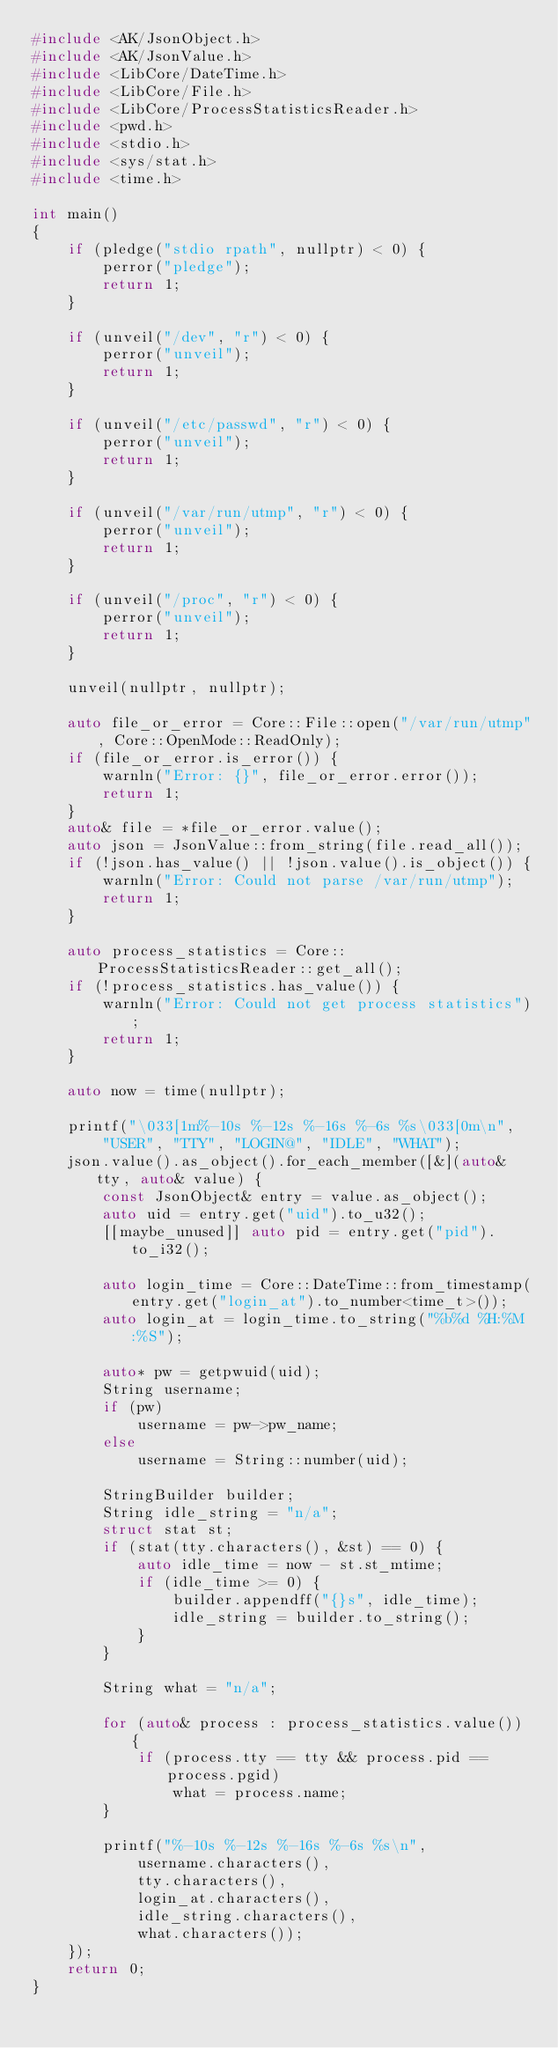Convert code to text. <code><loc_0><loc_0><loc_500><loc_500><_C++_>#include <AK/JsonObject.h>
#include <AK/JsonValue.h>
#include <LibCore/DateTime.h>
#include <LibCore/File.h>
#include <LibCore/ProcessStatisticsReader.h>
#include <pwd.h>
#include <stdio.h>
#include <sys/stat.h>
#include <time.h>

int main()
{
    if (pledge("stdio rpath", nullptr) < 0) {
        perror("pledge");
        return 1;
    }

    if (unveil("/dev", "r") < 0) {
        perror("unveil");
        return 1;
    }

    if (unveil("/etc/passwd", "r") < 0) {
        perror("unveil");
        return 1;
    }

    if (unveil("/var/run/utmp", "r") < 0) {
        perror("unveil");
        return 1;
    }

    if (unveil("/proc", "r") < 0) {
        perror("unveil");
        return 1;
    }

    unveil(nullptr, nullptr);

    auto file_or_error = Core::File::open("/var/run/utmp", Core::OpenMode::ReadOnly);
    if (file_or_error.is_error()) {
        warnln("Error: {}", file_or_error.error());
        return 1;
    }
    auto& file = *file_or_error.value();
    auto json = JsonValue::from_string(file.read_all());
    if (!json.has_value() || !json.value().is_object()) {
        warnln("Error: Could not parse /var/run/utmp");
        return 1;
    }

    auto process_statistics = Core::ProcessStatisticsReader::get_all();
    if (!process_statistics.has_value()) {
        warnln("Error: Could not get process statistics");
        return 1;
    }

    auto now = time(nullptr);

    printf("\033[1m%-10s %-12s %-16s %-6s %s\033[0m\n",
        "USER", "TTY", "LOGIN@", "IDLE", "WHAT");
    json.value().as_object().for_each_member([&](auto& tty, auto& value) {
        const JsonObject& entry = value.as_object();
        auto uid = entry.get("uid").to_u32();
        [[maybe_unused]] auto pid = entry.get("pid").to_i32();

        auto login_time = Core::DateTime::from_timestamp(entry.get("login_at").to_number<time_t>());
        auto login_at = login_time.to_string("%b%d %H:%M:%S");

        auto* pw = getpwuid(uid);
        String username;
        if (pw)
            username = pw->pw_name;
        else
            username = String::number(uid);

        StringBuilder builder;
        String idle_string = "n/a";
        struct stat st;
        if (stat(tty.characters(), &st) == 0) {
            auto idle_time = now - st.st_mtime;
            if (idle_time >= 0) {
                builder.appendff("{}s", idle_time);
                idle_string = builder.to_string();
            }
        }

        String what = "n/a";

        for (auto& process : process_statistics.value()) {
            if (process.tty == tty && process.pid == process.pgid)
                what = process.name;
        }

        printf("%-10s %-12s %-16s %-6s %s\n",
            username.characters(),
            tty.characters(),
            login_at.characters(),
            idle_string.characters(),
            what.characters());
    });
    return 0;
}
</code> 